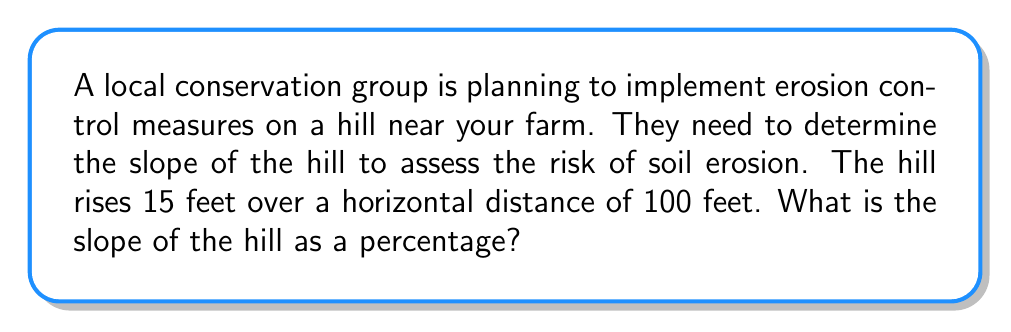Show me your answer to this math problem. Let's approach this step-by-step:

1) The slope of a hill can be calculated using the rise (vertical change) and run (horizontal distance) formula:

   $$ \text{Slope} = \frac{\text{Rise}}{\text{Run}} $$

2) In this case:
   Rise = 15 feet
   Run = 100 feet

3) Let's plug these values into our formula:

   $$ \text{Slope} = \frac{15 \text{ feet}}{100 \text{ feet}} = 0.15 $$

4) To convert this to a percentage, we multiply by 100:

   $$ 0.15 \times 100 = 15\% $$

5) Therefore, the slope of the hill is 15%.

This means that for every 100 feet of horizontal distance, the hill rises 15 feet. A 15% slope is considered moderate and may require some erosion control measures, especially in areas with heavy rainfall or snowmelt.
Answer: 15% 